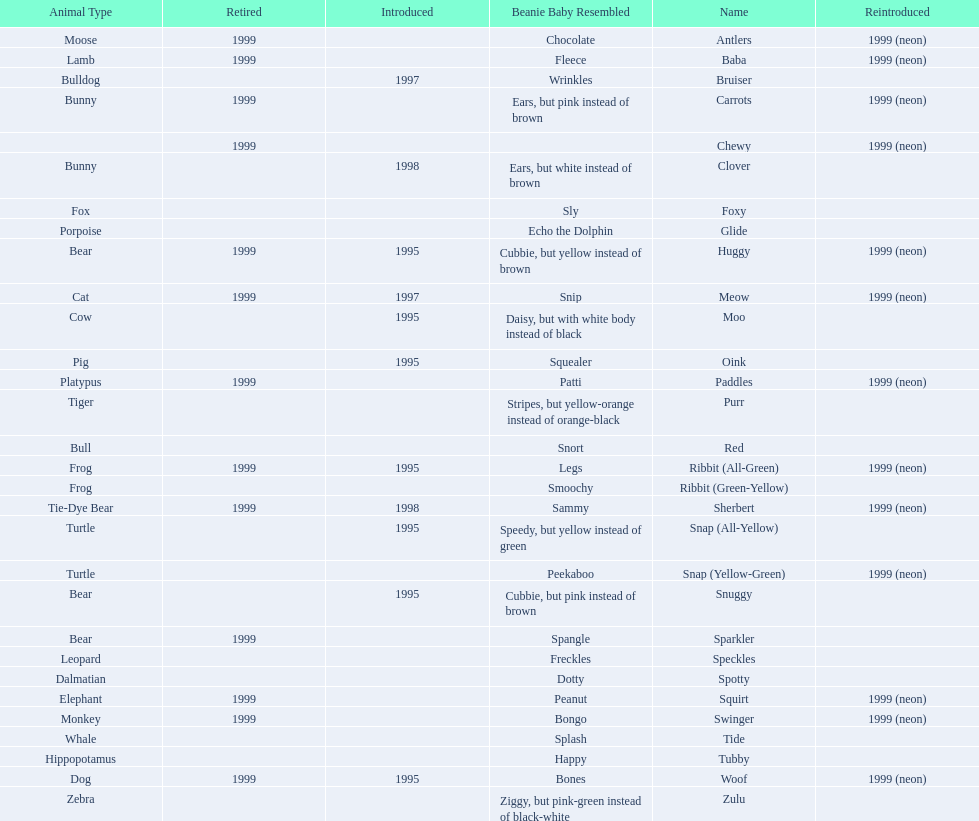What animals are pillow pals? Moose, Lamb, Bulldog, Bunny, Bunny, Fox, Porpoise, Bear, Cat, Cow, Pig, Platypus, Tiger, Bull, Frog, Frog, Tie-Dye Bear, Turtle, Turtle, Bear, Bear, Leopard, Dalmatian, Elephant, Monkey, Whale, Hippopotamus, Dog, Zebra. What is the name of the dalmatian? Spotty. 